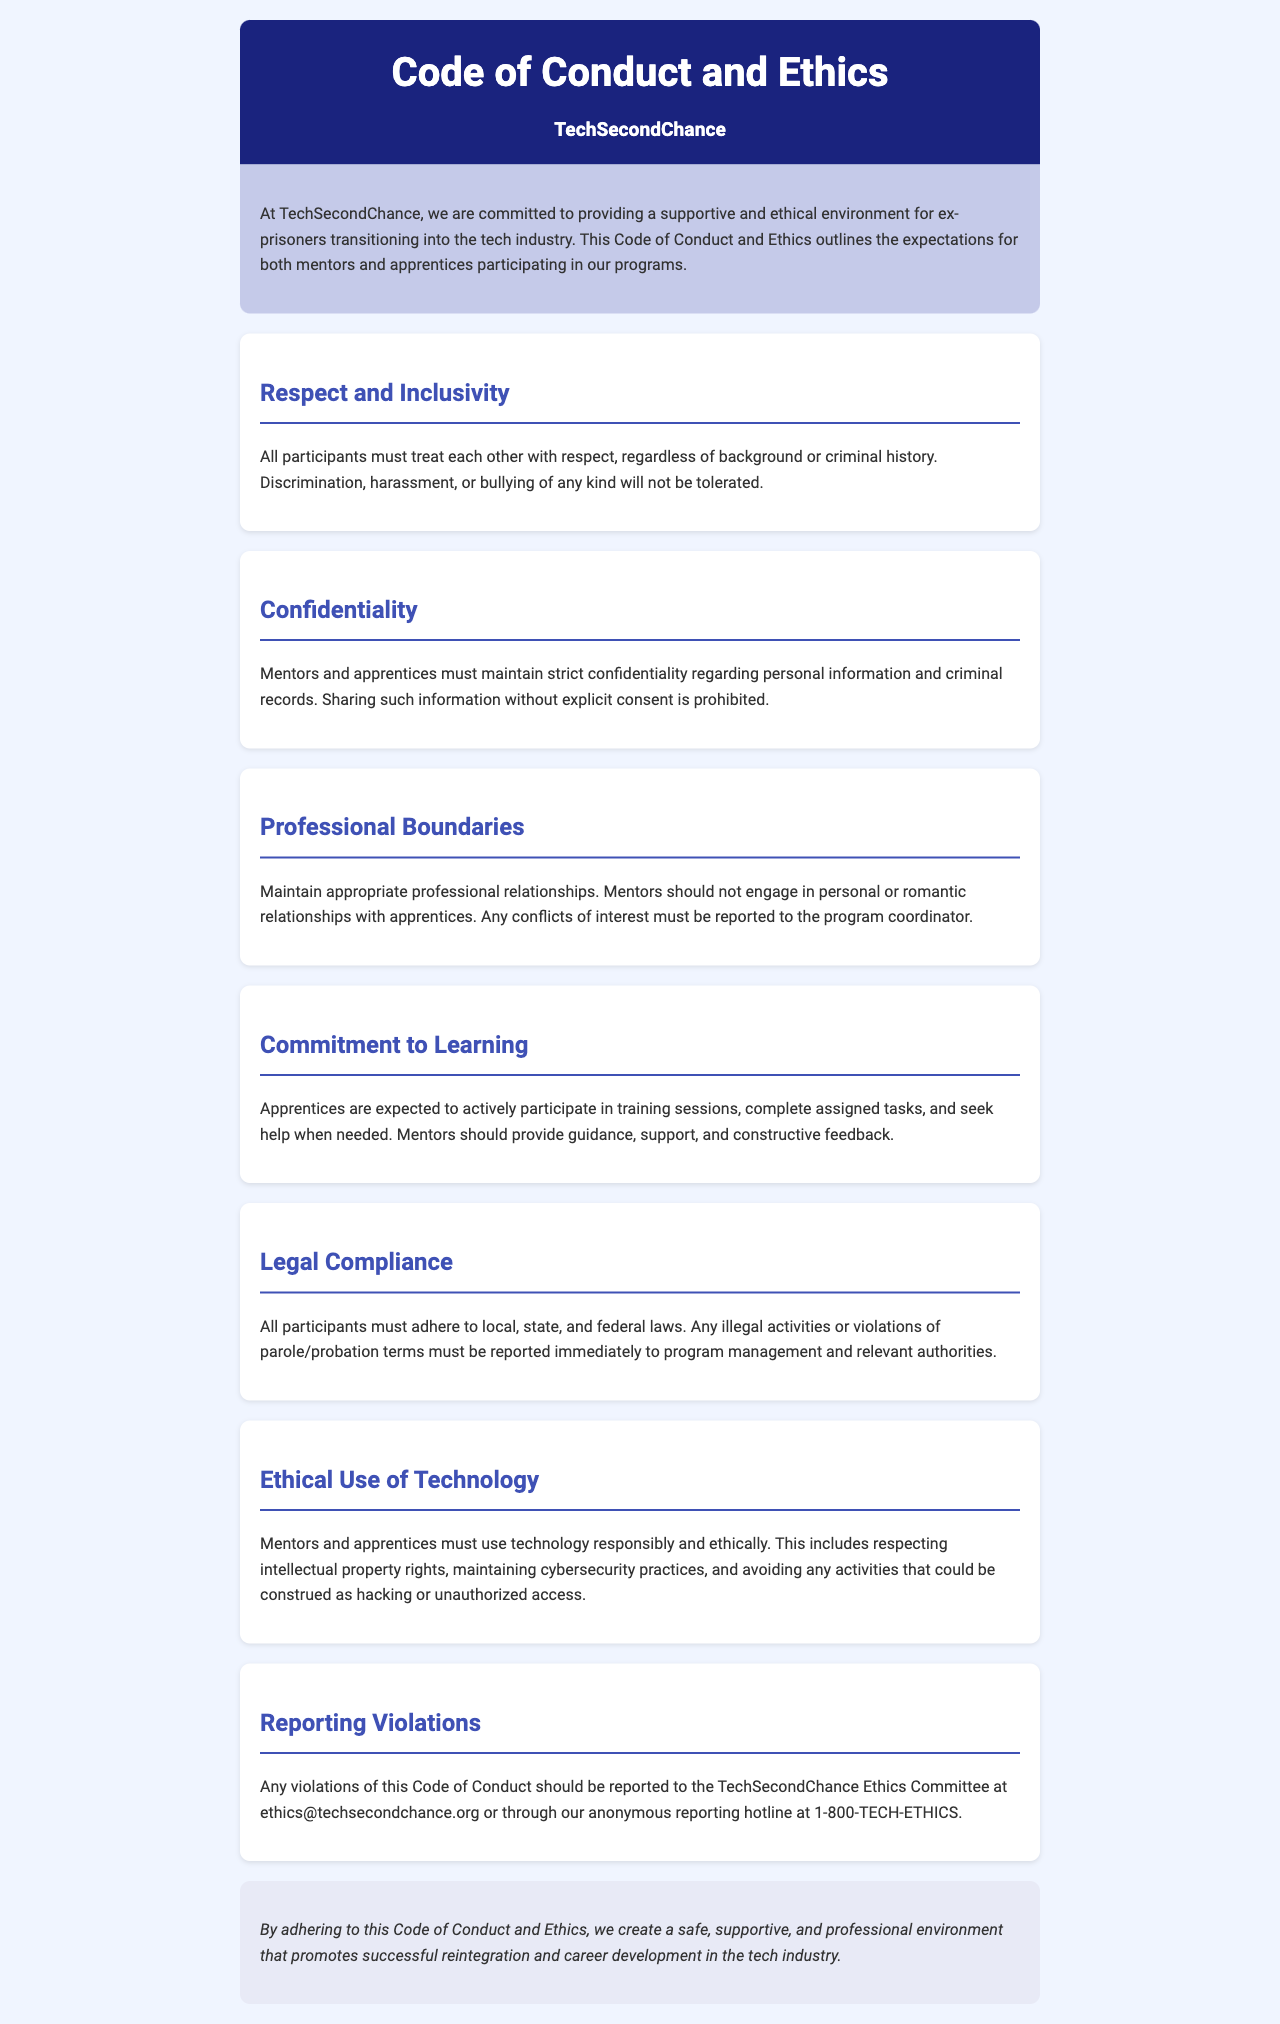What is the name of the company? The document introduces the company as TechSecondChance.
Answer: TechSecondChance What should participants maintain regarding personal information? The document specifically states that participants must maintain strict confidentiality regarding personal information.
Answer: Confidentiality What is prohibited in terms of relationships between mentors and apprentices? The document indicates that mentors should not engage in personal or romantic relationships with apprentices.
Answer: Personal or romantic relationships What email should violations be reported to? The document provides an email address for reporting violations, which is ethics@techsecondchance.org.
Answer: ethics@techsecondchance.org What should apprentices actively participate in? The document mentions that apprentices are expected to actively participate in training sessions.
Answer: Training sessions What action must be taken regarding illegal activities? The document states that any illegal activities must be reported immediately to program management and relevant authorities.
Answer: Report immediately What is the background color of the introduction section? The document describes the introduction section's background color as #c5cae9.
Answer: #c5cae9 How many sections are there in the document, excluding the introduction and conclusion? The document contains six sections between the introduction and conclusion.
Answer: Six What is outlined in the Code of Conduct and Ethics? The purpose of the document is to outline expectations for both mentors and apprentices participating in the programs.
Answer: Expectations 